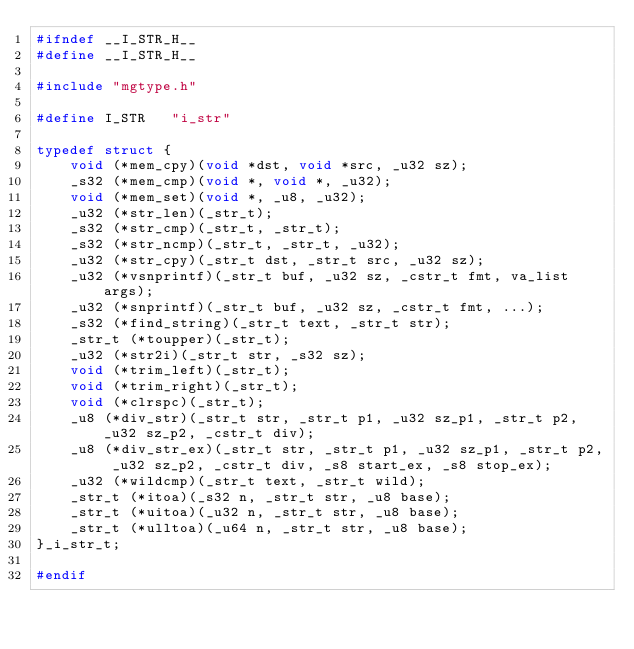Convert code to text. <code><loc_0><loc_0><loc_500><loc_500><_C_>#ifndef __I_STR_H__
#define __I_STR_H__

#include "mgtype.h"

#define I_STR	"i_str"

typedef struct {
	void (*mem_cpy)(void *dst, void *src, _u32 sz);
	_s32 (*mem_cmp)(void *, void *, _u32);
	void (*mem_set)(void *, _u8, _u32);
	_u32 (*str_len)(_str_t);
	_s32 (*str_cmp)(_str_t, _str_t);
	_s32 (*str_ncmp)(_str_t, _str_t, _u32);
	_u32 (*str_cpy)(_str_t dst, _str_t src, _u32 sz);
	_u32 (*vsnprintf)(_str_t buf, _u32 sz, _cstr_t fmt, va_list args);
	_u32 (*snprintf)(_str_t buf, _u32 sz, _cstr_t fmt, ...);
	_s32 (*find_string)(_str_t text, _str_t str);
	_str_t (*toupper)(_str_t);
	_u32 (*str2i)(_str_t str, _s32 sz);
	void (*trim_left)(_str_t);
	void (*trim_right)(_str_t);
	void (*clrspc)(_str_t);
	_u8 (*div_str)(_str_t str, _str_t p1, _u32 sz_p1, _str_t p2, _u32 sz_p2, _cstr_t div);
	_u8 (*div_str_ex)(_str_t str, _str_t p1, _u32 sz_p1, _str_t p2, _u32 sz_p2, _cstr_t div, _s8 start_ex, _s8 stop_ex);
	_u32 (*wildcmp)(_str_t text, _str_t wild);
	_str_t (*itoa)(_s32 n, _str_t str, _u8 base);
	_str_t (*uitoa)(_u32 n, _str_t str, _u8 base);
	_str_t (*ulltoa)(_u64 n, _str_t str, _u8 base);
}_i_str_t;

#endif
</code> 